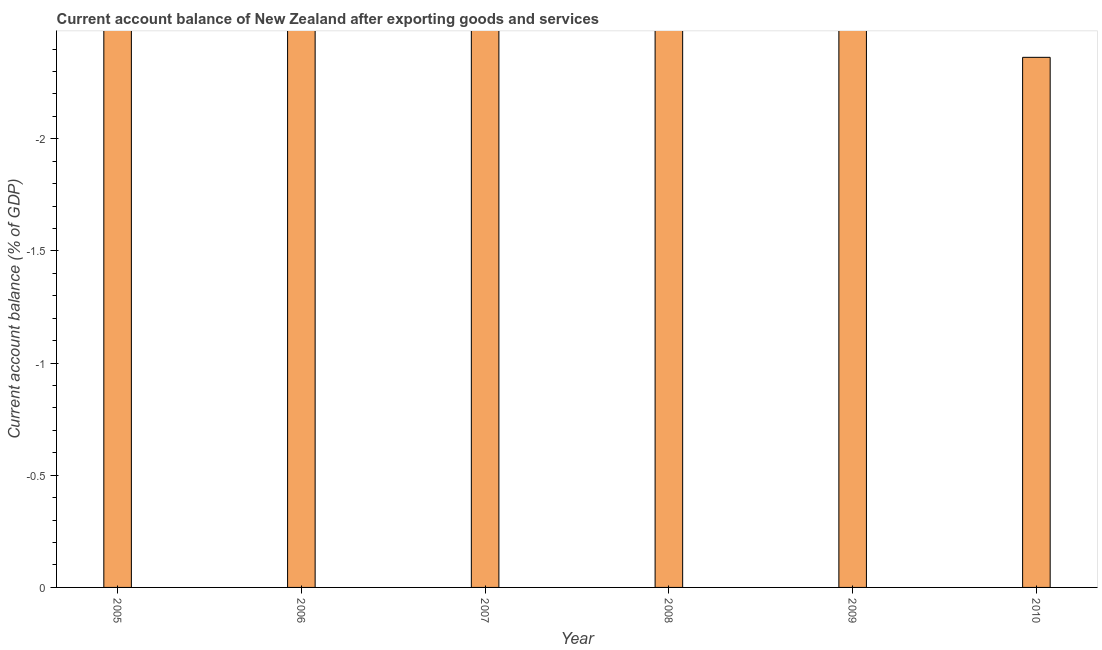Does the graph contain any zero values?
Keep it short and to the point. Yes. What is the title of the graph?
Your response must be concise. Current account balance of New Zealand after exporting goods and services. What is the label or title of the X-axis?
Your answer should be compact. Year. What is the label or title of the Y-axis?
Offer a terse response. Current account balance (% of GDP). What is the sum of the current account balance?
Ensure brevity in your answer.  0. What is the median current account balance?
Offer a terse response. 0. In how many years, is the current account balance greater than the average current account balance taken over all years?
Provide a succinct answer. 0. Are all the bars in the graph horizontal?
Make the answer very short. No. What is the difference between two consecutive major ticks on the Y-axis?
Offer a terse response. 0.5. Are the values on the major ticks of Y-axis written in scientific E-notation?
Offer a terse response. No. What is the Current account balance (% of GDP) in 2006?
Offer a very short reply. 0. What is the Current account balance (% of GDP) in 2007?
Provide a short and direct response. 0. What is the Current account balance (% of GDP) in 2009?
Offer a terse response. 0. What is the Current account balance (% of GDP) in 2010?
Keep it short and to the point. 0. 